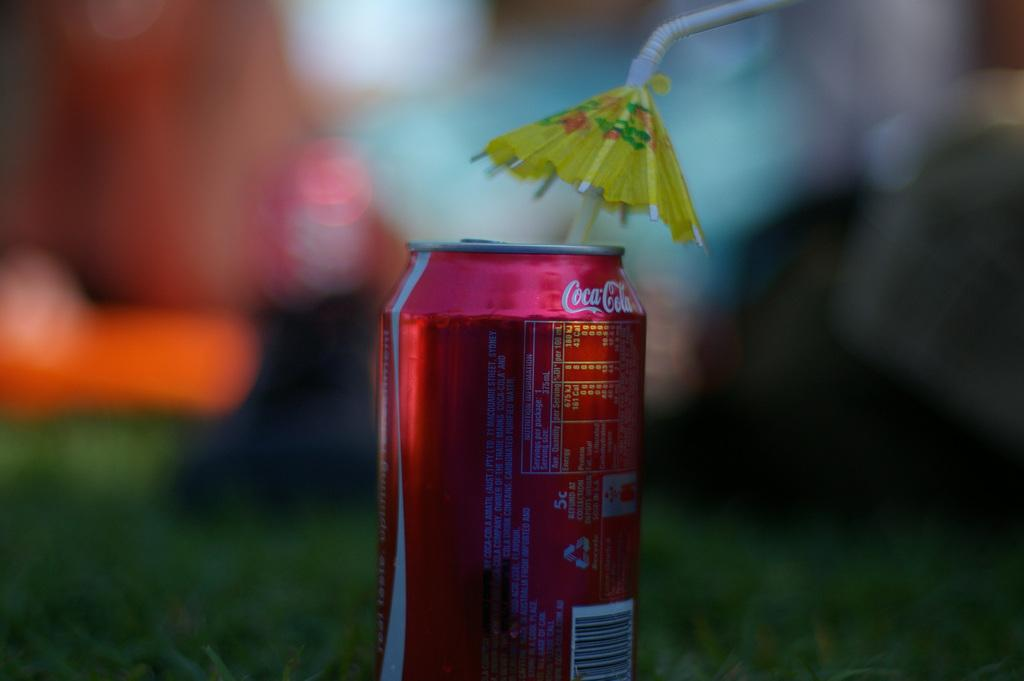What object is in the foreground of the image? There is a beverage can in the foreground of the image. What is placed with the beverage can in the foreground? There is a straw in the foreground of the image. Where are the beverage can and straw located? The beverage can and straw are on grass. Can you describe the possible setting of the image? The image may have been taken in a park, given the presence of grass. How many swings are visible in the image? There are no swings visible in the image; it only features a beverage can, a straw, and grass. Can you tell me how many people are joining the group in the image? There is no group or indication of people joining in the image; it only shows a beverage can, a straw, and grass. 